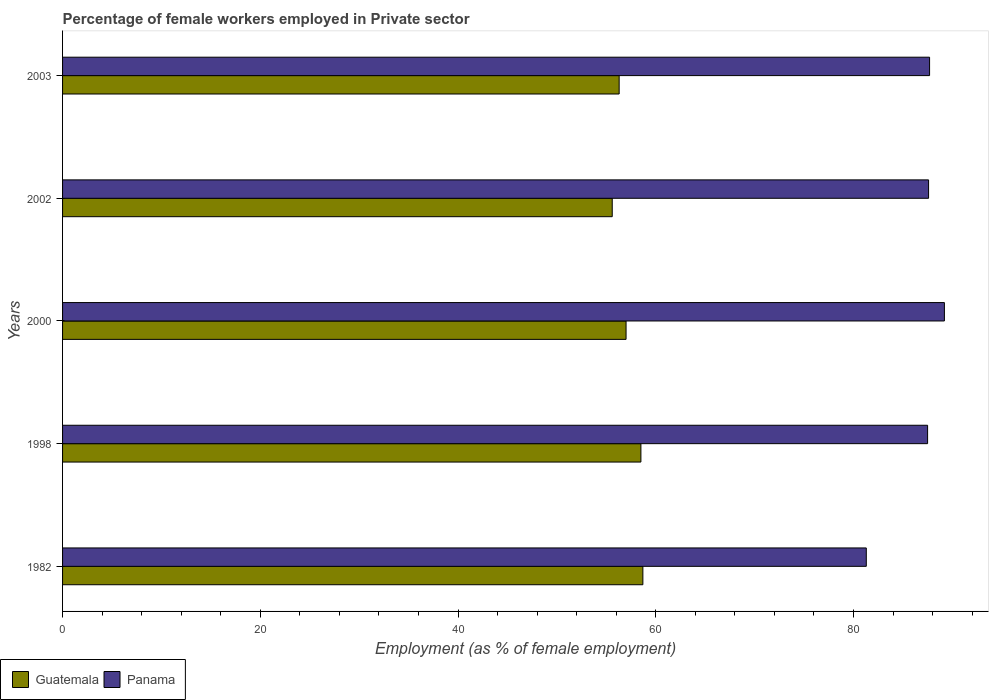How many different coloured bars are there?
Provide a succinct answer. 2. Are the number of bars on each tick of the Y-axis equal?
Provide a short and direct response. Yes. How many bars are there on the 1st tick from the top?
Your answer should be compact. 2. What is the label of the 2nd group of bars from the top?
Your answer should be very brief. 2002. What is the percentage of females employed in Private sector in Panama in 1998?
Offer a very short reply. 87.5. Across all years, what is the maximum percentage of females employed in Private sector in Panama?
Your answer should be compact. 89.2. Across all years, what is the minimum percentage of females employed in Private sector in Panama?
Provide a short and direct response. 81.3. In which year was the percentage of females employed in Private sector in Panama minimum?
Keep it short and to the point. 1982. What is the total percentage of females employed in Private sector in Guatemala in the graph?
Your response must be concise. 286.1. What is the difference between the percentage of females employed in Private sector in Guatemala in 1998 and the percentage of females employed in Private sector in Panama in 2003?
Provide a short and direct response. -29.2. What is the average percentage of females employed in Private sector in Panama per year?
Offer a terse response. 86.66. In the year 1982, what is the difference between the percentage of females employed in Private sector in Panama and percentage of females employed in Private sector in Guatemala?
Your answer should be compact. 22.6. What is the ratio of the percentage of females employed in Private sector in Guatemala in 2000 to that in 2003?
Keep it short and to the point. 1.01. Is the percentage of females employed in Private sector in Panama in 1982 less than that in 2002?
Ensure brevity in your answer.  Yes. Is the difference between the percentage of females employed in Private sector in Panama in 1998 and 2000 greater than the difference between the percentage of females employed in Private sector in Guatemala in 1998 and 2000?
Give a very brief answer. No. What is the difference between the highest and the second highest percentage of females employed in Private sector in Guatemala?
Your answer should be compact. 0.2. What is the difference between the highest and the lowest percentage of females employed in Private sector in Guatemala?
Make the answer very short. 3.1. What does the 2nd bar from the top in 1998 represents?
Make the answer very short. Guatemala. What does the 2nd bar from the bottom in 2003 represents?
Provide a succinct answer. Panama. How many bars are there?
Your answer should be very brief. 10. How many years are there in the graph?
Ensure brevity in your answer.  5. Are the values on the major ticks of X-axis written in scientific E-notation?
Offer a very short reply. No. How are the legend labels stacked?
Provide a short and direct response. Horizontal. What is the title of the graph?
Ensure brevity in your answer.  Percentage of female workers employed in Private sector. Does "Denmark" appear as one of the legend labels in the graph?
Your answer should be very brief. No. What is the label or title of the X-axis?
Provide a succinct answer. Employment (as % of female employment). What is the label or title of the Y-axis?
Offer a terse response. Years. What is the Employment (as % of female employment) in Guatemala in 1982?
Your answer should be very brief. 58.7. What is the Employment (as % of female employment) in Panama in 1982?
Keep it short and to the point. 81.3. What is the Employment (as % of female employment) of Guatemala in 1998?
Your answer should be compact. 58.5. What is the Employment (as % of female employment) in Panama in 1998?
Provide a succinct answer. 87.5. What is the Employment (as % of female employment) of Guatemala in 2000?
Provide a succinct answer. 57. What is the Employment (as % of female employment) in Panama in 2000?
Your answer should be compact. 89.2. What is the Employment (as % of female employment) in Guatemala in 2002?
Give a very brief answer. 55.6. What is the Employment (as % of female employment) in Panama in 2002?
Offer a very short reply. 87.6. What is the Employment (as % of female employment) in Guatemala in 2003?
Keep it short and to the point. 56.3. What is the Employment (as % of female employment) of Panama in 2003?
Offer a very short reply. 87.7. Across all years, what is the maximum Employment (as % of female employment) in Guatemala?
Give a very brief answer. 58.7. Across all years, what is the maximum Employment (as % of female employment) in Panama?
Your response must be concise. 89.2. Across all years, what is the minimum Employment (as % of female employment) in Guatemala?
Ensure brevity in your answer.  55.6. Across all years, what is the minimum Employment (as % of female employment) in Panama?
Provide a succinct answer. 81.3. What is the total Employment (as % of female employment) in Guatemala in the graph?
Provide a succinct answer. 286.1. What is the total Employment (as % of female employment) in Panama in the graph?
Offer a terse response. 433.3. What is the difference between the Employment (as % of female employment) in Guatemala in 1982 and that in 2000?
Your response must be concise. 1.7. What is the difference between the Employment (as % of female employment) of Guatemala in 1982 and that in 2002?
Your response must be concise. 3.1. What is the difference between the Employment (as % of female employment) in Guatemala in 1982 and that in 2003?
Provide a short and direct response. 2.4. What is the difference between the Employment (as % of female employment) of Panama in 1998 and that in 2000?
Your answer should be very brief. -1.7. What is the difference between the Employment (as % of female employment) of Guatemala in 1998 and that in 2002?
Provide a short and direct response. 2.9. What is the difference between the Employment (as % of female employment) in Panama in 1998 and that in 2002?
Keep it short and to the point. -0.1. What is the difference between the Employment (as % of female employment) of Guatemala in 2000 and that in 2002?
Offer a very short reply. 1.4. What is the difference between the Employment (as % of female employment) of Panama in 2000 and that in 2002?
Offer a very short reply. 1.6. What is the difference between the Employment (as % of female employment) in Guatemala in 2000 and that in 2003?
Your answer should be compact. 0.7. What is the difference between the Employment (as % of female employment) in Panama in 2002 and that in 2003?
Provide a short and direct response. -0.1. What is the difference between the Employment (as % of female employment) in Guatemala in 1982 and the Employment (as % of female employment) in Panama in 1998?
Keep it short and to the point. -28.8. What is the difference between the Employment (as % of female employment) in Guatemala in 1982 and the Employment (as % of female employment) in Panama in 2000?
Ensure brevity in your answer.  -30.5. What is the difference between the Employment (as % of female employment) in Guatemala in 1982 and the Employment (as % of female employment) in Panama in 2002?
Offer a very short reply. -28.9. What is the difference between the Employment (as % of female employment) in Guatemala in 1998 and the Employment (as % of female employment) in Panama in 2000?
Keep it short and to the point. -30.7. What is the difference between the Employment (as % of female employment) of Guatemala in 1998 and the Employment (as % of female employment) of Panama in 2002?
Make the answer very short. -29.1. What is the difference between the Employment (as % of female employment) of Guatemala in 1998 and the Employment (as % of female employment) of Panama in 2003?
Keep it short and to the point. -29.2. What is the difference between the Employment (as % of female employment) in Guatemala in 2000 and the Employment (as % of female employment) in Panama in 2002?
Give a very brief answer. -30.6. What is the difference between the Employment (as % of female employment) of Guatemala in 2000 and the Employment (as % of female employment) of Panama in 2003?
Your answer should be very brief. -30.7. What is the difference between the Employment (as % of female employment) of Guatemala in 2002 and the Employment (as % of female employment) of Panama in 2003?
Make the answer very short. -32.1. What is the average Employment (as % of female employment) of Guatemala per year?
Your answer should be compact. 57.22. What is the average Employment (as % of female employment) in Panama per year?
Make the answer very short. 86.66. In the year 1982, what is the difference between the Employment (as % of female employment) in Guatemala and Employment (as % of female employment) in Panama?
Offer a terse response. -22.6. In the year 1998, what is the difference between the Employment (as % of female employment) of Guatemala and Employment (as % of female employment) of Panama?
Your answer should be very brief. -29. In the year 2000, what is the difference between the Employment (as % of female employment) of Guatemala and Employment (as % of female employment) of Panama?
Your response must be concise. -32.2. In the year 2002, what is the difference between the Employment (as % of female employment) in Guatemala and Employment (as % of female employment) in Panama?
Your response must be concise. -32. In the year 2003, what is the difference between the Employment (as % of female employment) of Guatemala and Employment (as % of female employment) of Panama?
Your answer should be compact. -31.4. What is the ratio of the Employment (as % of female employment) in Panama in 1982 to that in 1998?
Offer a very short reply. 0.93. What is the ratio of the Employment (as % of female employment) in Guatemala in 1982 to that in 2000?
Offer a very short reply. 1.03. What is the ratio of the Employment (as % of female employment) in Panama in 1982 to that in 2000?
Provide a succinct answer. 0.91. What is the ratio of the Employment (as % of female employment) of Guatemala in 1982 to that in 2002?
Your answer should be very brief. 1.06. What is the ratio of the Employment (as % of female employment) in Panama in 1982 to that in 2002?
Provide a succinct answer. 0.93. What is the ratio of the Employment (as % of female employment) of Guatemala in 1982 to that in 2003?
Make the answer very short. 1.04. What is the ratio of the Employment (as % of female employment) in Panama in 1982 to that in 2003?
Provide a short and direct response. 0.93. What is the ratio of the Employment (as % of female employment) of Guatemala in 1998 to that in 2000?
Offer a very short reply. 1.03. What is the ratio of the Employment (as % of female employment) of Panama in 1998 to that in 2000?
Provide a short and direct response. 0.98. What is the ratio of the Employment (as % of female employment) in Guatemala in 1998 to that in 2002?
Your response must be concise. 1.05. What is the ratio of the Employment (as % of female employment) in Guatemala in 1998 to that in 2003?
Give a very brief answer. 1.04. What is the ratio of the Employment (as % of female employment) in Guatemala in 2000 to that in 2002?
Provide a short and direct response. 1.03. What is the ratio of the Employment (as % of female employment) in Panama in 2000 to that in 2002?
Ensure brevity in your answer.  1.02. What is the ratio of the Employment (as % of female employment) in Guatemala in 2000 to that in 2003?
Provide a succinct answer. 1.01. What is the ratio of the Employment (as % of female employment) of Panama in 2000 to that in 2003?
Provide a succinct answer. 1.02. What is the ratio of the Employment (as % of female employment) of Guatemala in 2002 to that in 2003?
Keep it short and to the point. 0.99. What is the difference between the highest and the second highest Employment (as % of female employment) of Guatemala?
Your response must be concise. 0.2. What is the difference between the highest and the lowest Employment (as % of female employment) in Panama?
Your response must be concise. 7.9. 